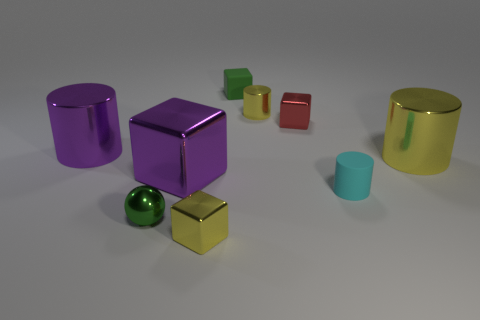Add 1 brown rubber cubes. How many objects exist? 10 Subtract all small yellow cylinders. How many cylinders are left? 3 Subtract all yellow blocks. How many yellow cylinders are left? 2 Subtract 2 cubes. How many cubes are left? 2 Subtract all green cubes. How many cubes are left? 3 Subtract all spheres. How many objects are left? 8 Subtract all cyan cylinders. Subtract all green cubes. How many cylinders are left? 3 Subtract all big blue matte cylinders. Subtract all cyan matte cylinders. How many objects are left? 8 Add 3 tiny yellow objects. How many tiny yellow objects are left? 5 Add 5 green shiny things. How many green shiny things exist? 6 